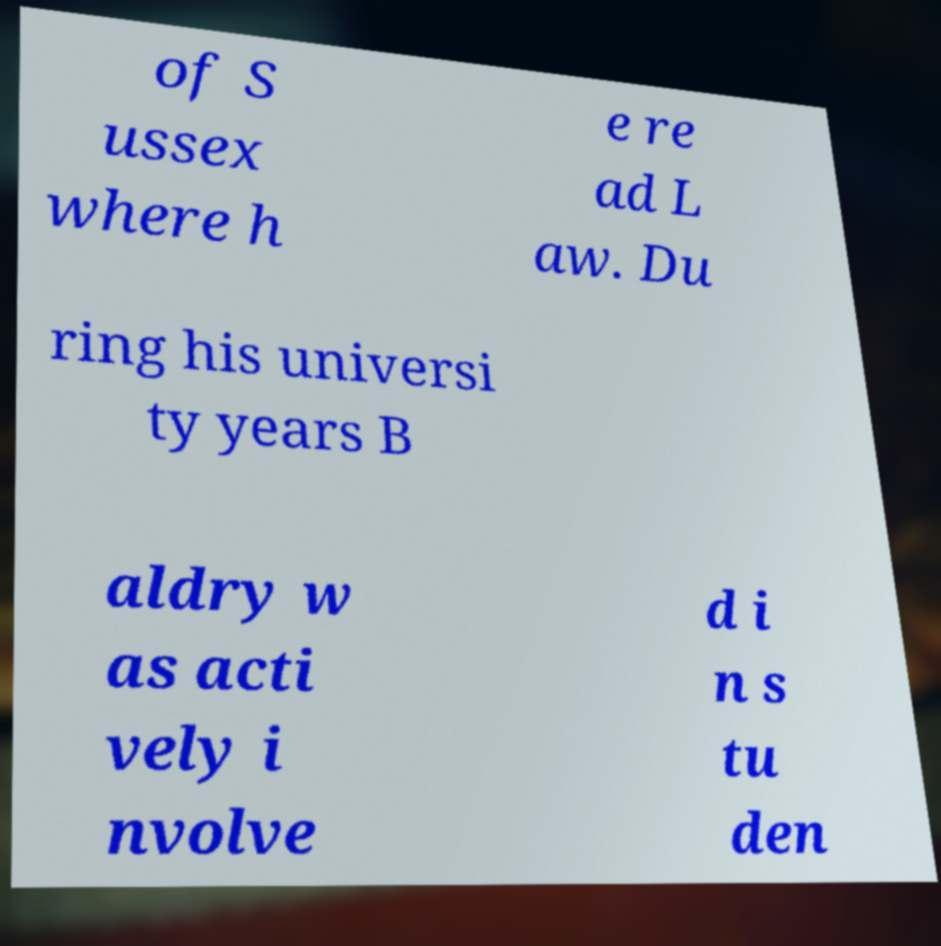There's text embedded in this image that I need extracted. Can you transcribe it verbatim? of S ussex where h e re ad L aw. Du ring his universi ty years B aldry w as acti vely i nvolve d i n s tu den 